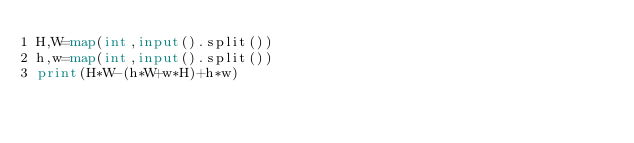Convert code to text. <code><loc_0><loc_0><loc_500><loc_500><_Python_>H,W=map(int,input().split())
h,w=map(int,input().split())
print(H*W-(h*W+w*H)+h*w)</code> 